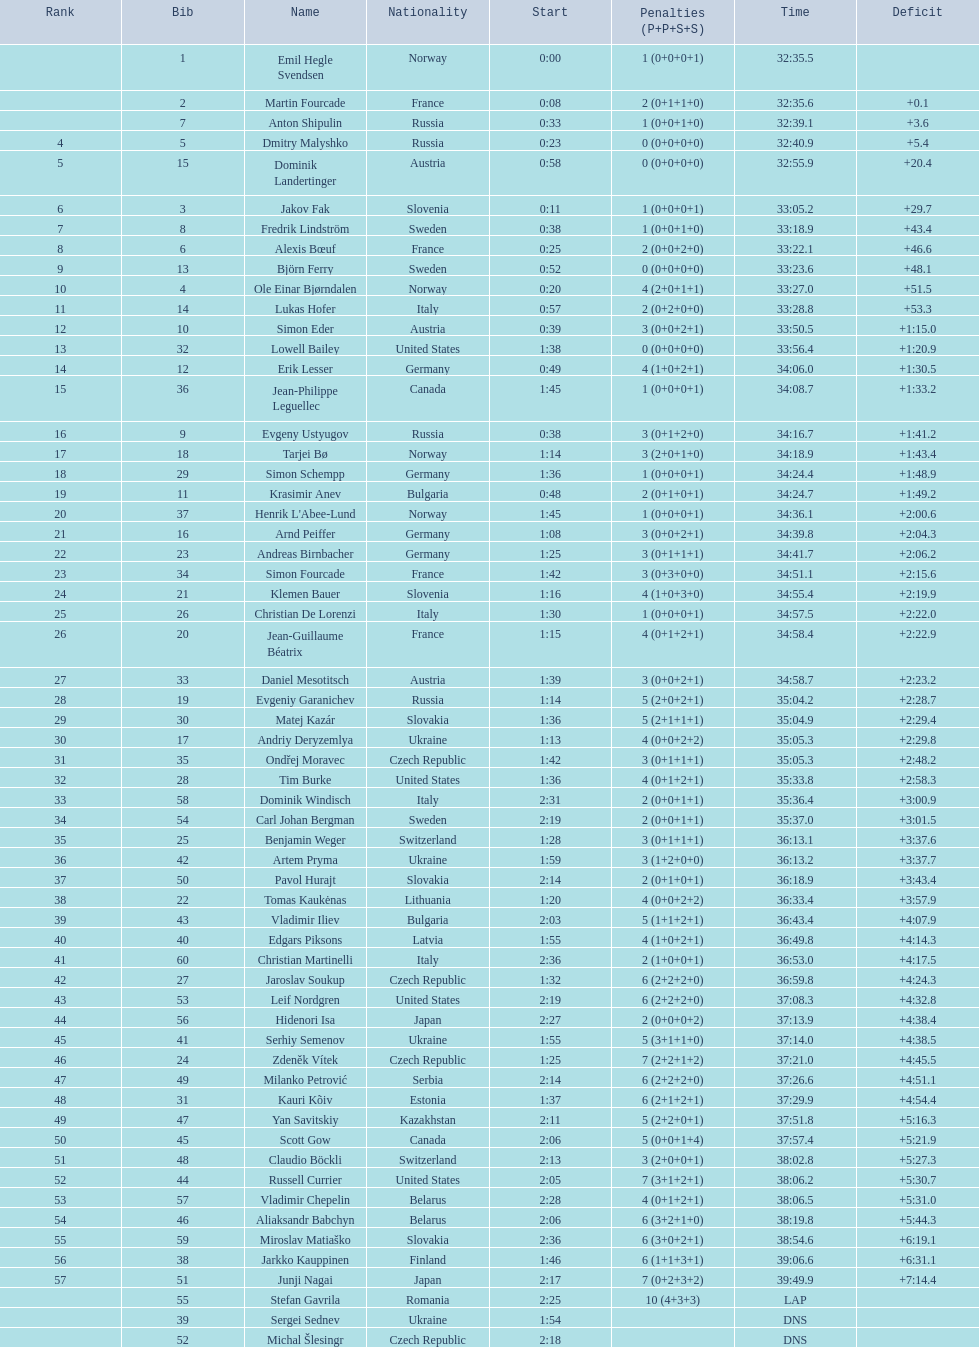What were the aggregate number of "ties" (people who concluded with the exact same time?) 2. Parse the table in full. {'header': ['Rank', 'Bib', 'Name', 'Nationality', 'Start', 'Penalties (P+P+S+S)', 'Time', 'Deficit'], 'rows': [['', '1', 'Emil Hegle Svendsen', 'Norway', '0:00', '1 (0+0+0+1)', '32:35.5', ''], ['', '2', 'Martin Fourcade', 'France', '0:08', '2 (0+1+1+0)', '32:35.6', '+0.1'], ['', '7', 'Anton Shipulin', 'Russia', '0:33', '1 (0+0+1+0)', '32:39.1', '+3.6'], ['4', '5', 'Dmitry Malyshko', 'Russia', '0:23', '0 (0+0+0+0)', '32:40.9', '+5.4'], ['5', '15', 'Dominik Landertinger', 'Austria', '0:58', '0 (0+0+0+0)', '32:55.9', '+20.4'], ['6', '3', 'Jakov Fak', 'Slovenia', '0:11', '1 (0+0+0+1)', '33:05.2', '+29.7'], ['7', '8', 'Fredrik Lindström', 'Sweden', '0:38', '1 (0+0+1+0)', '33:18.9', '+43.4'], ['8', '6', 'Alexis Bœuf', 'France', '0:25', '2 (0+0+2+0)', '33:22.1', '+46.6'], ['9', '13', 'Björn Ferry', 'Sweden', '0:52', '0 (0+0+0+0)', '33:23.6', '+48.1'], ['10', '4', 'Ole Einar Bjørndalen', 'Norway', '0:20', '4 (2+0+1+1)', '33:27.0', '+51.5'], ['11', '14', 'Lukas Hofer', 'Italy', '0:57', '2 (0+2+0+0)', '33:28.8', '+53.3'], ['12', '10', 'Simon Eder', 'Austria', '0:39', '3 (0+0+2+1)', '33:50.5', '+1:15.0'], ['13', '32', 'Lowell Bailey', 'United States', '1:38', '0 (0+0+0+0)', '33:56.4', '+1:20.9'], ['14', '12', 'Erik Lesser', 'Germany', '0:49', '4 (1+0+2+1)', '34:06.0', '+1:30.5'], ['15', '36', 'Jean-Philippe Leguellec', 'Canada', '1:45', '1 (0+0+0+1)', '34:08.7', '+1:33.2'], ['16', '9', 'Evgeny Ustyugov', 'Russia', '0:38', '3 (0+1+2+0)', '34:16.7', '+1:41.2'], ['17', '18', 'Tarjei Bø', 'Norway', '1:14', '3 (2+0+1+0)', '34:18.9', '+1:43.4'], ['18', '29', 'Simon Schempp', 'Germany', '1:36', '1 (0+0+0+1)', '34:24.4', '+1:48.9'], ['19', '11', 'Krasimir Anev', 'Bulgaria', '0:48', '2 (0+1+0+1)', '34:24.7', '+1:49.2'], ['20', '37', "Henrik L'Abee-Lund", 'Norway', '1:45', '1 (0+0+0+1)', '34:36.1', '+2:00.6'], ['21', '16', 'Arnd Peiffer', 'Germany', '1:08', '3 (0+0+2+1)', '34:39.8', '+2:04.3'], ['22', '23', 'Andreas Birnbacher', 'Germany', '1:25', '3 (0+1+1+1)', '34:41.7', '+2:06.2'], ['23', '34', 'Simon Fourcade', 'France', '1:42', '3 (0+3+0+0)', '34:51.1', '+2:15.6'], ['24', '21', 'Klemen Bauer', 'Slovenia', '1:16', '4 (1+0+3+0)', '34:55.4', '+2:19.9'], ['25', '26', 'Christian De Lorenzi', 'Italy', '1:30', '1 (0+0+0+1)', '34:57.5', '+2:22.0'], ['26', '20', 'Jean-Guillaume Béatrix', 'France', '1:15', '4 (0+1+2+1)', '34:58.4', '+2:22.9'], ['27', '33', 'Daniel Mesotitsch', 'Austria', '1:39', '3 (0+0+2+1)', '34:58.7', '+2:23.2'], ['28', '19', 'Evgeniy Garanichev', 'Russia', '1:14', '5 (2+0+2+1)', '35:04.2', '+2:28.7'], ['29', '30', 'Matej Kazár', 'Slovakia', '1:36', '5 (2+1+1+1)', '35:04.9', '+2:29.4'], ['30', '17', 'Andriy Deryzemlya', 'Ukraine', '1:13', '4 (0+0+2+2)', '35:05.3', '+2:29.8'], ['31', '35', 'Ondřej Moravec', 'Czech Republic', '1:42', '3 (0+1+1+1)', '35:05.3', '+2:48.2'], ['32', '28', 'Tim Burke', 'United States', '1:36', '4 (0+1+2+1)', '35:33.8', '+2:58.3'], ['33', '58', 'Dominik Windisch', 'Italy', '2:31', '2 (0+0+1+1)', '35:36.4', '+3:00.9'], ['34', '54', 'Carl Johan Bergman', 'Sweden', '2:19', '2 (0+0+1+1)', '35:37.0', '+3:01.5'], ['35', '25', 'Benjamin Weger', 'Switzerland', '1:28', '3 (0+1+1+1)', '36:13.1', '+3:37.6'], ['36', '42', 'Artem Pryma', 'Ukraine', '1:59', '3 (1+2+0+0)', '36:13.2', '+3:37.7'], ['37', '50', 'Pavol Hurajt', 'Slovakia', '2:14', '2 (0+1+0+1)', '36:18.9', '+3:43.4'], ['38', '22', 'Tomas Kaukėnas', 'Lithuania', '1:20', '4 (0+0+2+2)', '36:33.4', '+3:57.9'], ['39', '43', 'Vladimir Iliev', 'Bulgaria', '2:03', '5 (1+1+2+1)', '36:43.4', '+4:07.9'], ['40', '40', 'Edgars Piksons', 'Latvia', '1:55', '4 (1+0+2+1)', '36:49.8', '+4:14.3'], ['41', '60', 'Christian Martinelli', 'Italy', '2:36', '2 (1+0+0+1)', '36:53.0', '+4:17.5'], ['42', '27', 'Jaroslav Soukup', 'Czech Republic', '1:32', '6 (2+2+2+0)', '36:59.8', '+4:24.3'], ['43', '53', 'Leif Nordgren', 'United States', '2:19', '6 (2+2+2+0)', '37:08.3', '+4:32.8'], ['44', '56', 'Hidenori Isa', 'Japan', '2:27', '2 (0+0+0+2)', '37:13.9', '+4:38.4'], ['45', '41', 'Serhiy Semenov', 'Ukraine', '1:55', '5 (3+1+1+0)', '37:14.0', '+4:38.5'], ['46', '24', 'Zdeněk Vítek', 'Czech Republic', '1:25', '7 (2+2+1+2)', '37:21.0', '+4:45.5'], ['47', '49', 'Milanko Petrović', 'Serbia', '2:14', '6 (2+2+2+0)', '37:26.6', '+4:51.1'], ['48', '31', 'Kauri Kõiv', 'Estonia', '1:37', '6 (2+1+2+1)', '37:29.9', '+4:54.4'], ['49', '47', 'Yan Savitskiy', 'Kazakhstan', '2:11', '5 (2+2+0+1)', '37:51.8', '+5:16.3'], ['50', '45', 'Scott Gow', 'Canada', '2:06', '5 (0+0+1+4)', '37:57.4', '+5:21.9'], ['51', '48', 'Claudio Böckli', 'Switzerland', '2:13', '3 (2+0+0+1)', '38:02.8', '+5:27.3'], ['52', '44', 'Russell Currier', 'United States', '2:05', '7 (3+1+2+1)', '38:06.2', '+5:30.7'], ['53', '57', 'Vladimir Chepelin', 'Belarus', '2:28', '4 (0+1+2+1)', '38:06.5', '+5:31.0'], ['54', '46', 'Aliaksandr Babchyn', 'Belarus', '2:06', '6 (3+2+1+0)', '38:19.8', '+5:44.3'], ['55', '59', 'Miroslav Matiaško', 'Slovakia', '2:36', '6 (3+0+2+1)', '38:54.6', '+6:19.1'], ['56', '38', 'Jarkko Kauppinen', 'Finland', '1:46', '6 (1+1+3+1)', '39:06.6', '+6:31.1'], ['57', '51', 'Junji Nagai', 'Japan', '2:17', '7 (0+2+3+2)', '39:49.9', '+7:14.4'], ['', '55', 'Stefan Gavrila', 'Romania', '2:25', '10 (4+3+3)', 'LAP', ''], ['', '39', 'Sergei Sednev', 'Ukraine', '1:54', '', 'DNS', ''], ['', '52', 'Michal Šlesingr', 'Czech Republic', '2:18', '', 'DNS', '']]} 